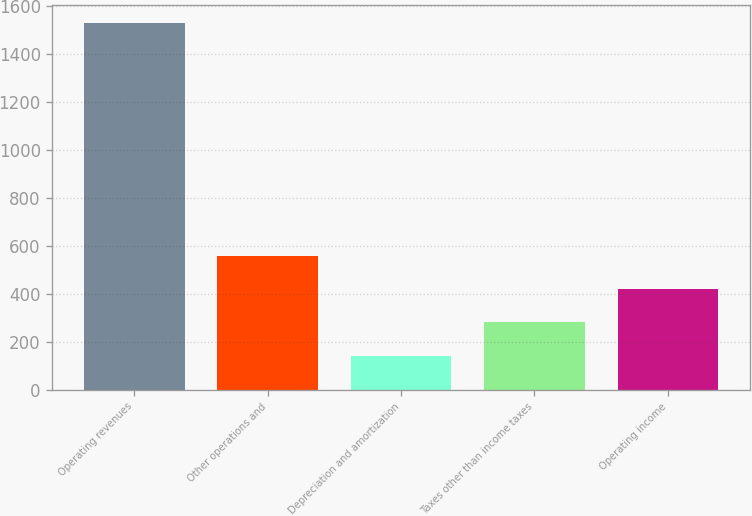Convert chart. <chart><loc_0><loc_0><loc_500><loc_500><bar_chart><fcel>Operating revenues<fcel>Other operations and<fcel>Depreciation and amortization<fcel>Taxes other than income taxes<fcel>Operating income<nl><fcel>1527<fcel>557.5<fcel>142<fcel>280.5<fcel>419<nl></chart> 